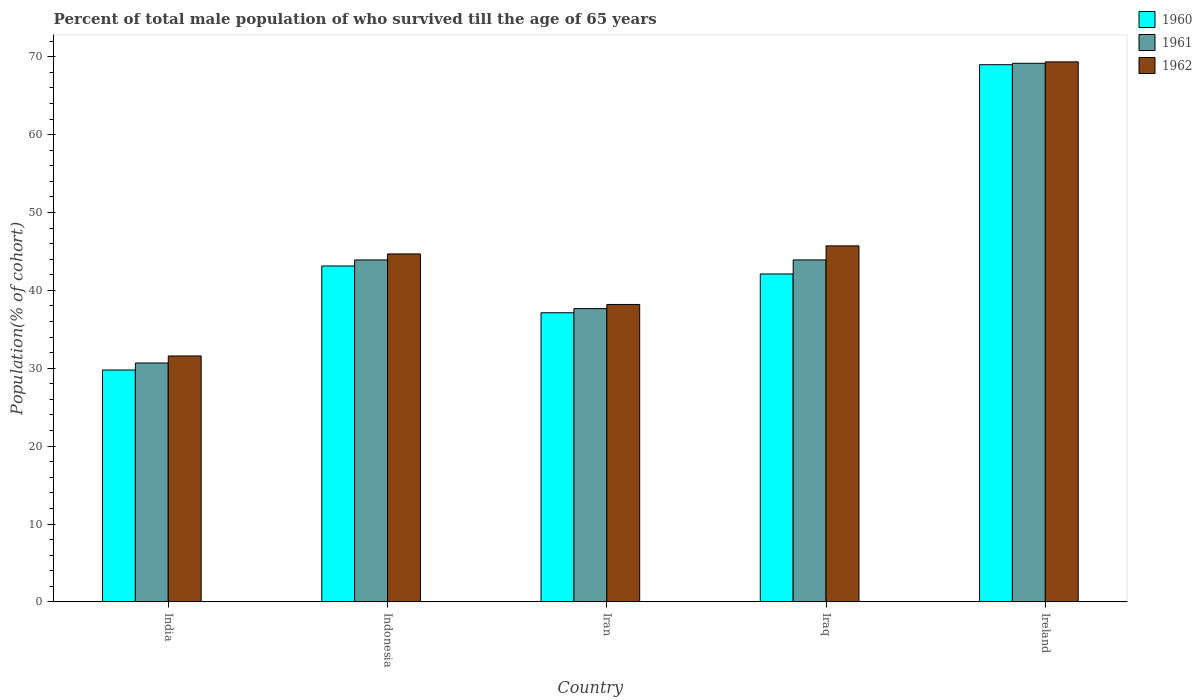How many different coloured bars are there?
Provide a short and direct response. 3. How many groups of bars are there?
Give a very brief answer. 5. Are the number of bars per tick equal to the number of legend labels?
Provide a succinct answer. Yes. How many bars are there on the 1st tick from the left?
Ensure brevity in your answer.  3. What is the label of the 3rd group of bars from the left?
Offer a terse response. Iran. What is the percentage of total male population who survived till the age of 65 years in 1961 in Ireland?
Keep it short and to the point. 69.17. Across all countries, what is the maximum percentage of total male population who survived till the age of 65 years in 1960?
Provide a short and direct response. 68.98. Across all countries, what is the minimum percentage of total male population who survived till the age of 65 years in 1961?
Ensure brevity in your answer.  30.68. In which country was the percentage of total male population who survived till the age of 65 years in 1961 maximum?
Provide a short and direct response. Ireland. What is the total percentage of total male population who survived till the age of 65 years in 1961 in the graph?
Your response must be concise. 225.33. What is the difference between the percentage of total male population who survived till the age of 65 years in 1961 in India and that in Indonesia?
Your answer should be very brief. -13.23. What is the difference between the percentage of total male population who survived till the age of 65 years in 1961 in India and the percentage of total male population who survived till the age of 65 years in 1960 in Indonesia?
Your answer should be compact. -12.46. What is the average percentage of total male population who survived till the age of 65 years in 1962 per country?
Ensure brevity in your answer.  45.9. What is the difference between the percentage of total male population who survived till the age of 65 years of/in 1961 and percentage of total male population who survived till the age of 65 years of/in 1960 in Iraq?
Ensure brevity in your answer.  1.8. In how many countries, is the percentage of total male population who survived till the age of 65 years in 1961 greater than 36 %?
Provide a succinct answer. 4. What is the ratio of the percentage of total male population who survived till the age of 65 years in 1960 in India to that in Indonesia?
Your answer should be very brief. 0.69. Is the percentage of total male population who survived till the age of 65 years in 1961 in Iraq less than that in Ireland?
Offer a terse response. Yes. What is the difference between the highest and the second highest percentage of total male population who survived till the age of 65 years in 1960?
Provide a succinct answer. -1.03. What is the difference between the highest and the lowest percentage of total male population who survived till the age of 65 years in 1961?
Provide a succinct answer. 38.49. Is the sum of the percentage of total male population who survived till the age of 65 years in 1960 in India and Indonesia greater than the maximum percentage of total male population who survived till the age of 65 years in 1962 across all countries?
Keep it short and to the point. Yes. Is it the case that in every country, the sum of the percentage of total male population who survived till the age of 65 years in 1960 and percentage of total male population who survived till the age of 65 years in 1961 is greater than the percentage of total male population who survived till the age of 65 years in 1962?
Offer a terse response. Yes. Are the values on the major ticks of Y-axis written in scientific E-notation?
Your answer should be compact. No. Does the graph contain any zero values?
Offer a very short reply. No. Does the graph contain grids?
Make the answer very short. No. Where does the legend appear in the graph?
Your response must be concise. Top right. How are the legend labels stacked?
Your response must be concise. Vertical. What is the title of the graph?
Offer a very short reply. Percent of total male population of who survived till the age of 65 years. Does "1997" appear as one of the legend labels in the graph?
Keep it short and to the point. No. What is the label or title of the Y-axis?
Keep it short and to the point. Population(% of cohort). What is the Population(% of cohort) of 1960 in India?
Your answer should be very brief. 29.78. What is the Population(% of cohort) of 1961 in India?
Give a very brief answer. 30.68. What is the Population(% of cohort) in 1962 in India?
Offer a very short reply. 31.58. What is the Population(% of cohort) of 1960 in Indonesia?
Ensure brevity in your answer.  43.14. What is the Population(% of cohort) in 1961 in Indonesia?
Your response must be concise. 43.91. What is the Population(% of cohort) of 1962 in Indonesia?
Offer a very short reply. 44.69. What is the Population(% of cohort) of 1960 in Iran?
Provide a succinct answer. 37.13. What is the Population(% of cohort) of 1961 in Iran?
Make the answer very short. 37.66. What is the Population(% of cohort) in 1962 in Iran?
Provide a succinct answer. 38.19. What is the Population(% of cohort) in 1960 in Iraq?
Make the answer very short. 42.11. What is the Population(% of cohort) in 1961 in Iraq?
Your response must be concise. 43.92. What is the Population(% of cohort) in 1962 in Iraq?
Your answer should be very brief. 45.72. What is the Population(% of cohort) in 1960 in Ireland?
Provide a short and direct response. 68.98. What is the Population(% of cohort) of 1961 in Ireland?
Your answer should be compact. 69.17. What is the Population(% of cohort) of 1962 in Ireland?
Make the answer very short. 69.35. Across all countries, what is the maximum Population(% of cohort) in 1960?
Give a very brief answer. 68.98. Across all countries, what is the maximum Population(% of cohort) in 1961?
Provide a succinct answer. 69.17. Across all countries, what is the maximum Population(% of cohort) of 1962?
Provide a short and direct response. 69.35. Across all countries, what is the minimum Population(% of cohort) in 1960?
Provide a short and direct response. 29.78. Across all countries, what is the minimum Population(% of cohort) in 1961?
Your response must be concise. 30.68. Across all countries, what is the minimum Population(% of cohort) in 1962?
Your response must be concise. 31.58. What is the total Population(% of cohort) of 1960 in the graph?
Offer a very short reply. 221.14. What is the total Population(% of cohort) of 1961 in the graph?
Keep it short and to the point. 225.33. What is the total Population(% of cohort) in 1962 in the graph?
Offer a very short reply. 229.52. What is the difference between the Population(% of cohort) in 1960 in India and that in Indonesia?
Ensure brevity in your answer.  -13.36. What is the difference between the Population(% of cohort) of 1961 in India and that in Indonesia?
Your answer should be very brief. -13.23. What is the difference between the Population(% of cohort) of 1962 in India and that in Indonesia?
Provide a short and direct response. -13.11. What is the difference between the Population(% of cohort) of 1960 in India and that in Iran?
Offer a very short reply. -7.36. What is the difference between the Population(% of cohort) in 1961 in India and that in Iran?
Keep it short and to the point. -6.99. What is the difference between the Population(% of cohort) in 1962 in India and that in Iran?
Provide a succinct answer. -6.61. What is the difference between the Population(% of cohort) in 1960 in India and that in Iraq?
Your answer should be very brief. -12.34. What is the difference between the Population(% of cohort) of 1961 in India and that in Iraq?
Provide a succinct answer. -13.24. What is the difference between the Population(% of cohort) in 1962 in India and that in Iraq?
Make the answer very short. -14.14. What is the difference between the Population(% of cohort) in 1960 in India and that in Ireland?
Your answer should be very brief. -39.21. What is the difference between the Population(% of cohort) in 1961 in India and that in Ireland?
Keep it short and to the point. -38.49. What is the difference between the Population(% of cohort) in 1962 in India and that in Ireland?
Your answer should be compact. -37.77. What is the difference between the Population(% of cohort) in 1960 in Indonesia and that in Iran?
Your answer should be compact. 6.01. What is the difference between the Population(% of cohort) in 1961 in Indonesia and that in Iran?
Provide a succinct answer. 6.25. What is the difference between the Population(% of cohort) in 1962 in Indonesia and that in Iran?
Your response must be concise. 6.49. What is the difference between the Population(% of cohort) of 1960 in Indonesia and that in Iraq?
Your answer should be very brief. 1.03. What is the difference between the Population(% of cohort) of 1961 in Indonesia and that in Iraq?
Make the answer very short. -0. What is the difference between the Population(% of cohort) in 1962 in Indonesia and that in Iraq?
Keep it short and to the point. -1.03. What is the difference between the Population(% of cohort) of 1960 in Indonesia and that in Ireland?
Offer a terse response. -25.85. What is the difference between the Population(% of cohort) of 1961 in Indonesia and that in Ireland?
Ensure brevity in your answer.  -25.25. What is the difference between the Population(% of cohort) of 1962 in Indonesia and that in Ireland?
Ensure brevity in your answer.  -24.66. What is the difference between the Population(% of cohort) of 1960 in Iran and that in Iraq?
Offer a terse response. -4.98. What is the difference between the Population(% of cohort) of 1961 in Iran and that in Iraq?
Make the answer very short. -6.25. What is the difference between the Population(% of cohort) in 1962 in Iran and that in Iraq?
Offer a very short reply. -7.52. What is the difference between the Population(% of cohort) in 1960 in Iran and that in Ireland?
Offer a terse response. -31.85. What is the difference between the Population(% of cohort) in 1961 in Iran and that in Ireland?
Your answer should be very brief. -31.5. What is the difference between the Population(% of cohort) in 1962 in Iran and that in Ireland?
Keep it short and to the point. -31.15. What is the difference between the Population(% of cohort) of 1960 in Iraq and that in Ireland?
Ensure brevity in your answer.  -26.87. What is the difference between the Population(% of cohort) of 1961 in Iraq and that in Ireland?
Make the answer very short. -25.25. What is the difference between the Population(% of cohort) in 1962 in Iraq and that in Ireland?
Offer a very short reply. -23.63. What is the difference between the Population(% of cohort) of 1960 in India and the Population(% of cohort) of 1961 in Indonesia?
Offer a very short reply. -14.14. What is the difference between the Population(% of cohort) in 1960 in India and the Population(% of cohort) in 1962 in Indonesia?
Offer a very short reply. -14.91. What is the difference between the Population(% of cohort) in 1961 in India and the Population(% of cohort) in 1962 in Indonesia?
Offer a terse response. -14.01. What is the difference between the Population(% of cohort) of 1960 in India and the Population(% of cohort) of 1961 in Iran?
Provide a short and direct response. -7.89. What is the difference between the Population(% of cohort) in 1960 in India and the Population(% of cohort) in 1962 in Iran?
Provide a short and direct response. -8.42. What is the difference between the Population(% of cohort) in 1961 in India and the Population(% of cohort) in 1962 in Iran?
Offer a very short reply. -7.52. What is the difference between the Population(% of cohort) in 1960 in India and the Population(% of cohort) in 1961 in Iraq?
Ensure brevity in your answer.  -14.14. What is the difference between the Population(% of cohort) in 1960 in India and the Population(% of cohort) in 1962 in Iraq?
Provide a short and direct response. -15.94. What is the difference between the Population(% of cohort) of 1961 in India and the Population(% of cohort) of 1962 in Iraq?
Keep it short and to the point. -15.04. What is the difference between the Population(% of cohort) of 1960 in India and the Population(% of cohort) of 1961 in Ireland?
Keep it short and to the point. -39.39. What is the difference between the Population(% of cohort) of 1960 in India and the Population(% of cohort) of 1962 in Ireland?
Your response must be concise. -39.57. What is the difference between the Population(% of cohort) of 1961 in India and the Population(% of cohort) of 1962 in Ireland?
Offer a very short reply. -38.67. What is the difference between the Population(% of cohort) in 1960 in Indonesia and the Population(% of cohort) in 1961 in Iran?
Your answer should be very brief. 5.48. What is the difference between the Population(% of cohort) of 1960 in Indonesia and the Population(% of cohort) of 1962 in Iran?
Offer a terse response. 4.94. What is the difference between the Population(% of cohort) of 1961 in Indonesia and the Population(% of cohort) of 1962 in Iran?
Give a very brief answer. 5.72. What is the difference between the Population(% of cohort) in 1960 in Indonesia and the Population(% of cohort) in 1961 in Iraq?
Keep it short and to the point. -0.78. What is the difference between the Population(% of cohort) in 1960 in Indonesia and the Population(% of cohort) in 1962 in Iraq?
Offer a terse response. -2.58. What is the difference between the Population(% of cohort) in 1961 in Indonesia and the Population(% of cohort) in 1962 in Iraq?
Provide a succinct answer. -1.81. What is the difference between the Population(% of cohort) in 1960 in Indonesia and the Population(% of cohort) in 1961 in Ireland?
Keep it short and to the point. -26.03. What is the difference between the Population(% of cohort) in 1960 in Indonesia and the Population(% of cohort) in 1962 in Ireland?
Your answer should be very brief. -26.21. What is the difference between the Population(% of cohort) in 1961 in Indonesia and the Population(% of cohort) in 1962 in Ireland?
Ensure brevity in your answer.  -25.44. What is the difference between the Population(% of cohort) of 1960 in Iran and the Population(% of cohort) of 1961 in Iraq?
Give a very brief answer. -6.78. What is the difference between the Population(% of cohort) of 1960 in Iran and the Population(% of cohort) of 1962 in Iraq?
Your answer should be very brief. -8.59. What is the difference between the Population(% of cohort) in 1961 in Iran and the Population(% of cohort) in 1962 in Iraq?
Make the answer very short. -8.06. What is the difference between the Population(% of cohort) of 1960 in Iran and the Population(% of cohort) of 1961 in Ireland?
Make the answer very short. -32.03. What is the difference between the Population(% of cohort) of 1960 in Iran and the Population(% of cohort) of 1962 in Ireland?
Offer a terse response. -32.22. What is the difference between the Population(% of cohort) of 1961 in Iran and the Population(% of cohort) of 1962 in Ireland?
Give a very brief answer. -31.68. What is the difference between the Population(% of cohort) of 1960 in Iraq and the Population(% of cohort) of 1961 in Ireland?
Keep it short and to the point. -27.05. What is the difference between the Population(% of cohort) in 1960 in Iraq and the Population(% of cohort) in 1962 in Ireland?
Your response must be concise. -27.24. What is the difference between the Population(% of cohort) of 1961 in Iraq and the Population(% of cohort) of 1962 in Ireland?
Provide a succinct answer. -25.43. What is the average Population(% of cohort) in 1960 per country?
Offer a terse response. 44.23. What is the average Population(% of cohort) in 1961 per country?
Give a very brief answer. 45.07. What is the average Population(% of cohort) of 1962 per country?
Make the answer very short. 45.9. What is the difference between the Population(% of cohort) of 1960 and Population(% of cohort) of 1961 in India?
Your response must be concise. -0.9. What is the difference between the Population(% of cohort) in 1960 and Population(% of cohort) in 1962 in India?
Your answer should be very brief. -1.8. What is the difference between the Population(% of cohort) of 1961 and Population(% of cohort) of 1962 in India?
Offer a very short reply. -0.9. What is the difference between the Population(% of cohort) of 1960 and Population(% of cohort) of 1961 in Indonesia?
Your answer should be very brief. -0.77. What is the difference between the Population(% of cohort) in 1960 and Population(% of cohort) in 1962 in Indonesia?
Your answer should be very brief. -1.55. What is the difference between the Population(% of cohort) in 1961 and Population(% of cohort) in 1962 in Indonesia?
Give a very brief answer. -0.77. What is the difference between the Population(% of cohort) in 1960 and Population(% of cohort) in 1961 in Iran?
Provide a short and direct response. -0.53. What is the difference between the Population(% of cohort) of 1960 and Population(% of cohort) of 1962 in Iran?
Make the answer very short. -1.06. What is the difference between the Population(% of cohort) in 1961 and Population(% of cohort) in 1962 in Iran?
Your response must be concise. -0.53. What is the difference between the Population(% of cohort) in 1960 and Population(% of cohort) in 1961 in Iraq?
Make the answer very short. -1.8. What is the difference between the Population(% of cohort) in 1960 and Population(% of cohort) in 1962 in Iraq?
Your answer should be compact. -3.61. What is the difference between the Population(% of cohort) in 1961 and Population(% of cohort) in 1962 in Iraq?
Provide a short and direct response. -1.8. What is the difference between the Population(% of cohort) of 1960 and Population(% of cohort) of 1961 in Ireland?
Offer a terse response. -0.18. What is the difference between the Population(% of cohort) of 1960 and Population(% of cohort) of 1962 in Ireland?
Offer a terse response. -0.36. What is the difference between the Population(% of cohort) in 1961 and Population(% of cohort) in 1962 in Ireland?
Offer a terse response. -0.18. What is the ratio of the Population(% of cohort) of 1960 in India to that in Indonesia?
Your answer should be very brief. 0.69. What is the ratio of the Population(% of cohort) of 1961 in India to that in Indonesia?
Your answer should be compact. 0.7. What is the ratio of the Population(% of cohort) in 1962 in India to that in Indonesia?
Make the answer very short. 0.71. What is the ratio of the Population(% of cohort) in 1960 in India to that in Iran?
Keep it short and to the point. 0.8. What is the ratio of the Population(% of cohort) in 1961 in India to that in Iran?
Give a very brief answer. 0.81. What is the ratio of the Population(% of cohort) in 1962 in India to that in Iran?
Ensure brevity in your answer.  0.83. What is the ratio of the Population(% of cohort) in 1960 in India to that in Iraq?
Provide a short and direct response. 0.71. What is the ratio of the Population(% of cohort) in 1961 in India to that in Iraq?
Your answer should be compact. 0.7. What is the ratio of the Population(% of cohort) of 1962 in India to that in Iraq?
Make the answer very short. 0.69. What is the ratio of the Population(% of cohort) in 1960 in India to that in Ireland?
Offer a very short reply. 0.43. What is the ratio of the Population(% of cohort) in 1961 in India to that in Ireland?
Give a very brief answer. 0.44. What is the ratio of the Population(% of cohort) in 1962 in India to that in Ireland?
Give a very brief answer. 0.46. What is the ratio of the Population(% of cohort) of 1960 in Indonesia to that in Iran?
Your answer should be very brief. 1.16. What is the ratio of the Population(% of cohort) in 1961 in Indonesia to that in Iran?
Keep it short and to the point. 1.17. What is the ratio of the Population(% of cohort) of 1962 in Indonesia to that in Iran?
Give a very brief answer. 1.17. What is the ratio of the Population(% of cohort) in 1960 in Indonesia to that in Iraq?
Provide a succinct answer. 1.02. What is the ratio of the Population(% of cohort) of 1961 in Indonesia to that in Iraq?
Offer a terse response. 1. What is the ratio of the Population(% of cohort) in 1962 in Indonesia to that in Iraq?
Provide a succinct answer. 0.98. What is the ratio of the Population(% of cohort) of 1960 in Indonesia to that in Ireland?
Your answer should be very brief. 0.63. What is the ratio of the Population(% of cohort) of 1961 in Indonesia to that in Ireland?
Give a very brief answer. 0.63. What is the ratio of the Population(% of cohort) in 1962 in Indonesia to that in Ireland?
Your answer should be compact. 0.64. What is the ratio of the Population(% of cohort) in 1960 in Iran to that in Iraq?
Your response must be concise. 0.88. What is the ratio of the Population(% of cohort) in 1961 in Iran to that in Iraq?
Offer a very short reply. 0.86. What is the ratio of the Population(% of cohort) in 1962 in Iran to that in Iraq?
Your response must be concise. 0.84. What is the ratio of the Population(% of cohort) of 1960 in Iran to that in Ireland?
Provide a succinct answer. 0.54. What is the ratio of the Population(% of cohort) in 1961 in Iran to that in Ireland?
Your answer should be very brief. 0.54. What is the ratio of the Population(% of cohort) in 1962 in Iran to that in Ireland?
Offer a very short reply. 0.55. What is the ratio of the Population(% of cohort) of 1960 in Iraq to that in Ireland?
Ensure brevity in your answer.  0.61. What is the ratio of the Population(% of cohort) in 1961 in Iraq to that in Ireland?
Offer a terse response. 0.63. What is the ratio of the Population(% of cohort) of 1962 in Iraq to that in Ireland?
Keep it short and to the point. 0.66. What is the difference between the highest and the second highest Population(% of cohort) of 1960?
Make the answer very short. 25.85. What is the difference between the highest and the second highest Population(% of cohort) in 1961?
Offer a very short reply. 25.25. What is the difference between the highest and the second highest Population(% of cohort) in 1962?
Your answer should be compact. 23.63. What is the difference between the highest and the lowest Population(% of cohort) of 1960?
Your response must be concise. 39.21. What is the difference between the highest and the lowest Population(% of cohort) of 1961?
Keep it short and to the point. 38.49. What is the difference between the highest and the lowest Population(% of cohort) of 1962?
Your answer should be compact. 37.77. 